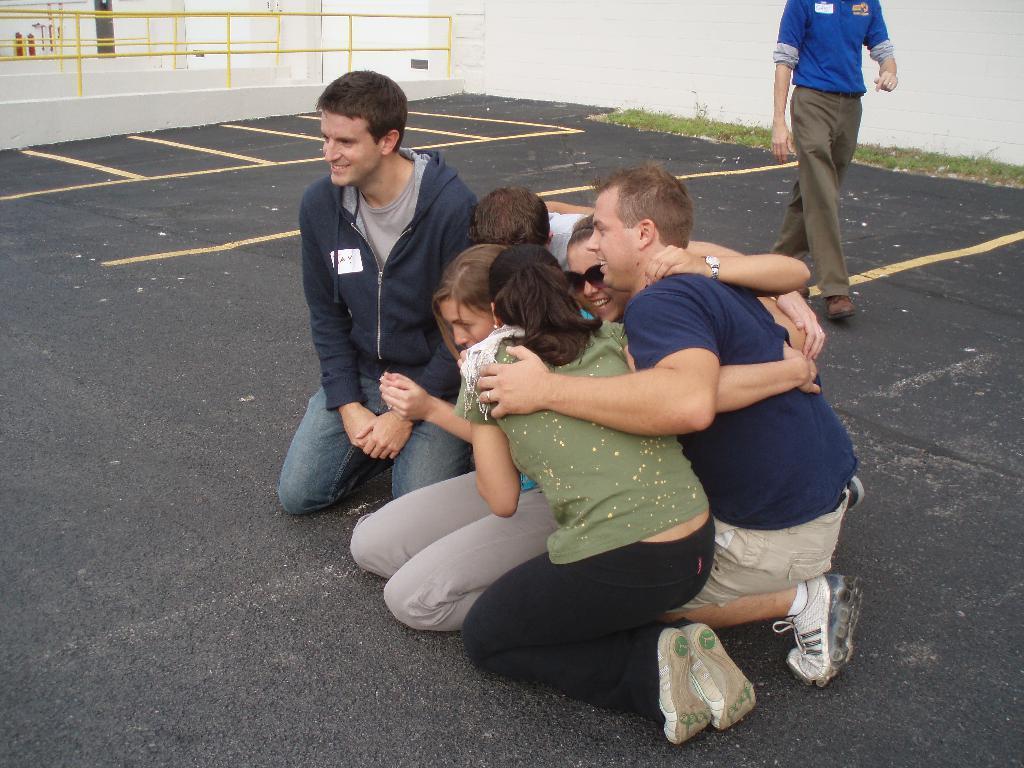Can you describe this image briefly? In this image group of people was sitting on the road. Behind them there is a person walking. At the left side of the image metal fencing was done. 